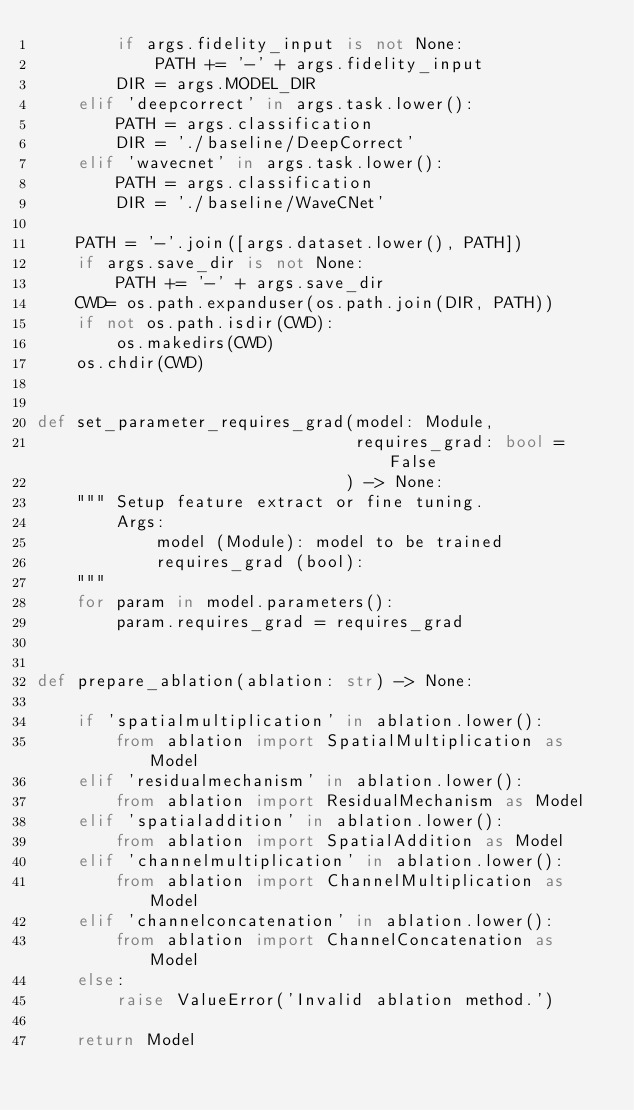Convert code to text. <code><loc_0><loc_0><loc_500><loc_500><_Python_>        if args.fidelity_input is not None:
            PATH += '-' + args.fidelity_input
        DIR = args.MODEL_DIR
    elif 'deepcorrect' in args.task.lower():
        PATH = args.classification
        DIR = './baseline/DeepCorrect'
    elif 'wavecnet' in args.task.lower():
        PATH = args.classification
        DIR = './baseline/WaveCNet'
    
    PATH = '-'.join([args.dataset.lower(), PATH])
    if args.save_dir is not None:
        PATH += '-' + args.save_dir
    CWD= os.path.expanduser(os.path.join(DIR, PATH))    
    if not os.path.isdir(CWD):
        os.makedirs(CWD)
    os.chdir(CWD)
    

def set_parameter_requires_grad(model: Module, 
                                requires_grad: bool = False
                               ) -> None:
    """ Setup feature extract or fine tuning.
        Args:
            model (Module): model to be trained
            requires_grad (bool):
    """
    for param in model.parameters():
        param.requires_grad = requires_grad
        
        
def prepare_ablation(ablation: str) -> None:
    
    if 'spatialmultiplication' in ablation.lower():
        from ablation import SpatialMultiplication as Model
    elif 'residualmechanism' in ablation.lower():
        from ablation import ResidualMechanism as Model
    elif 'spatialaddition' in ablation.lower():
        from ablation import SpatialAddition as Model
    elif 'channelmultiplication' in ablation.lower():
        from ablation import ChannelMultiplication as Model
    elif 'channelconcatenation' in ablation.lower():
        from ablation import ChannelConcatenation as Model
    else:
        raise ValueError('Invalid ablation method.')
    
    return Model</code> 